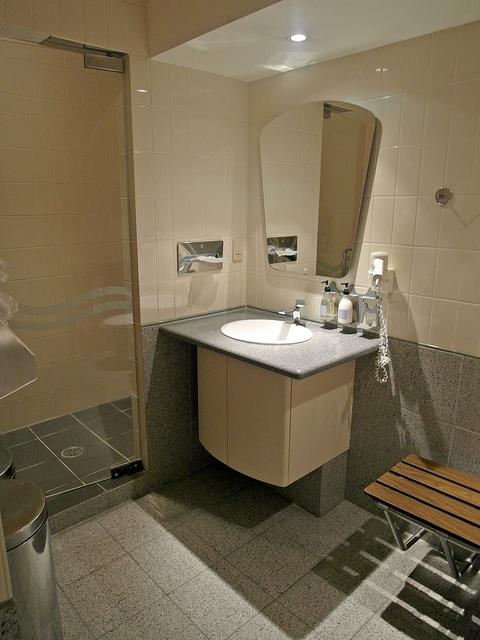What usually happens in this room? shower 